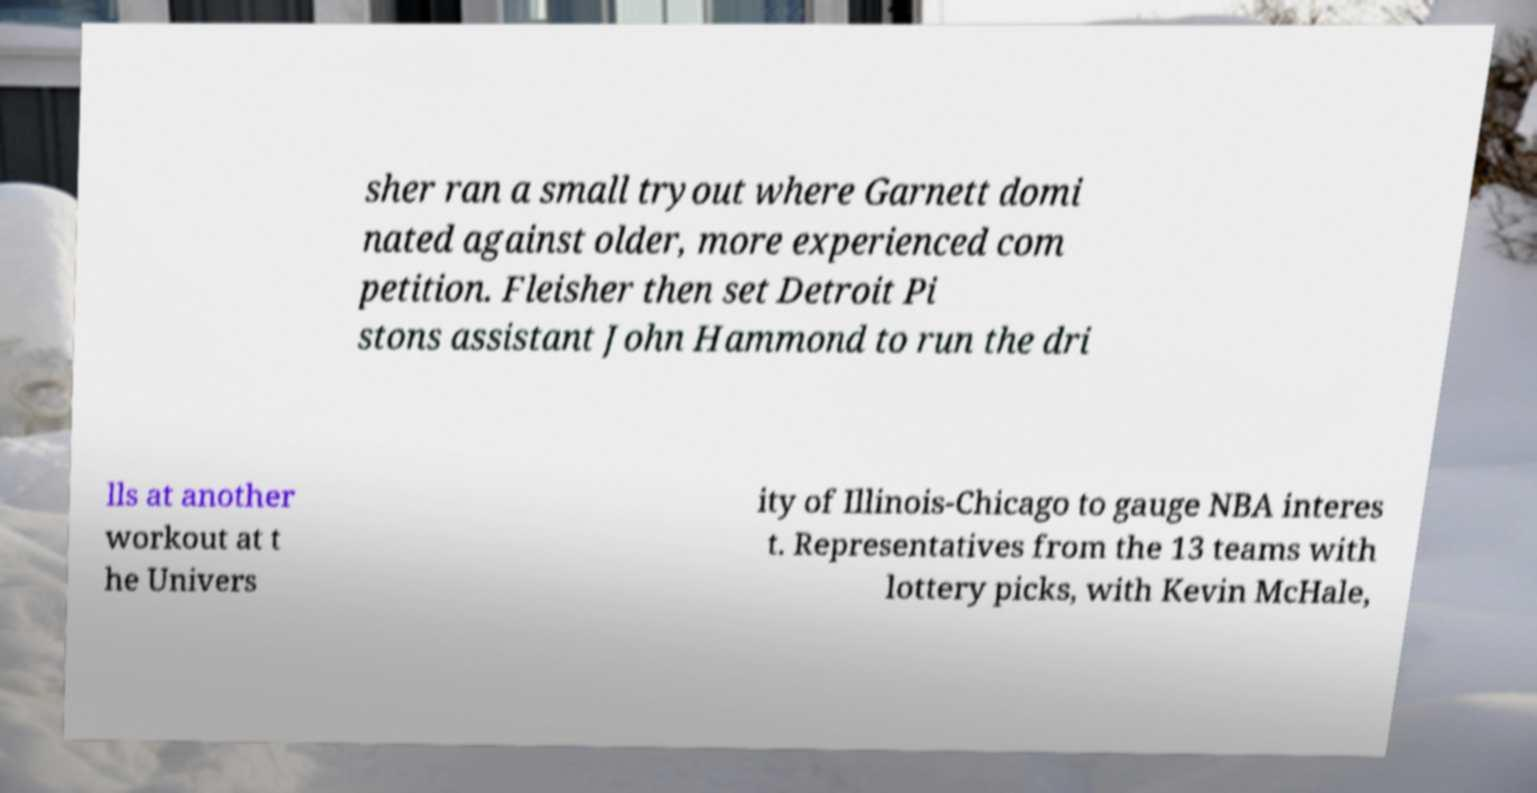There's text embedded in this image that I need extracted. Can you transcribe it verbatim? sher ran a small tryout where Garnett domi nated against older, more experienced com petition. Fleisher then set Detroit Pi stons assistant John Hammond to run the dri lls at another workout at t he Univers ity of Illinois-Chicago to gauge NBA interes t. Representatives from the 13 teams with lottery picks, with Kevin McHale, 